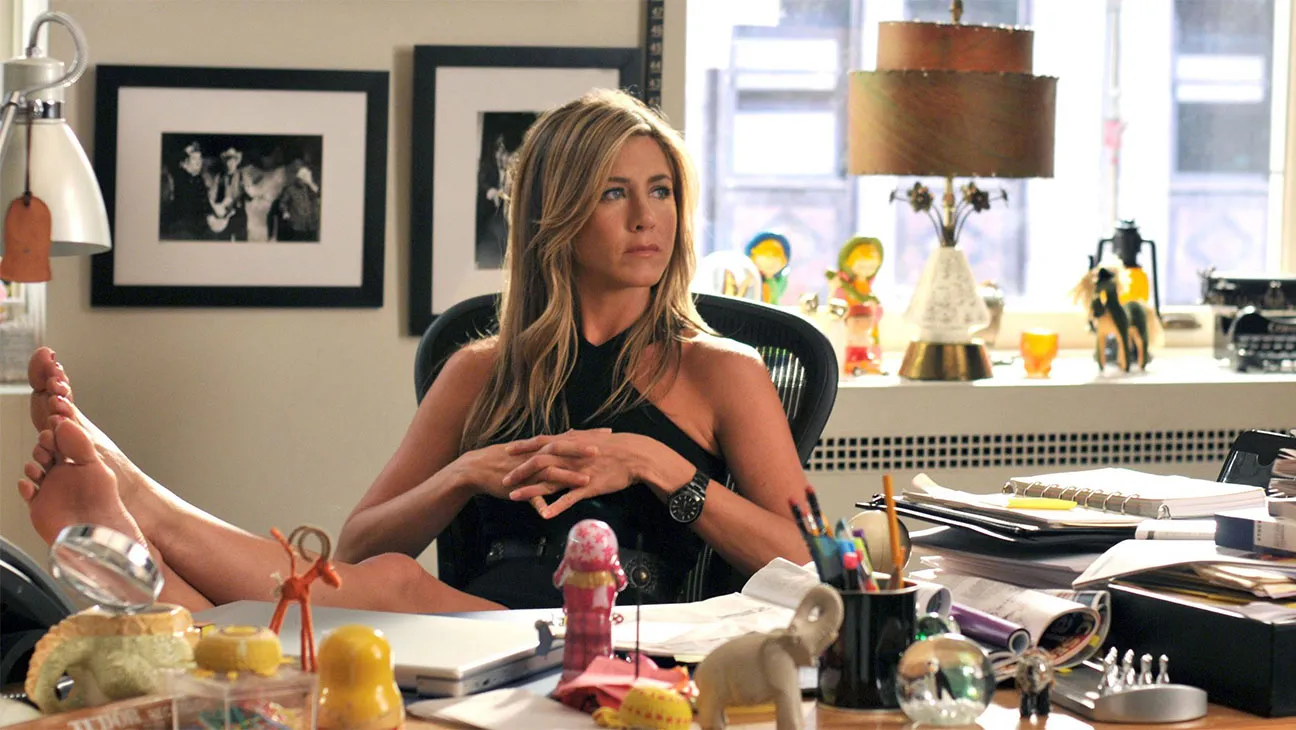Can you tell me more about the items on the desk? Certainly! The desk in the image is strewn with various items that suggest creativity and personalization. There's a red figure made of bendable material, a pink snow globe-like object, and various other trinkets that add color and personality. Additionally, practical items such as a mobile phone, a lamp, and a stack of papers indicate active use of the space, blending functionality with personal flair. 